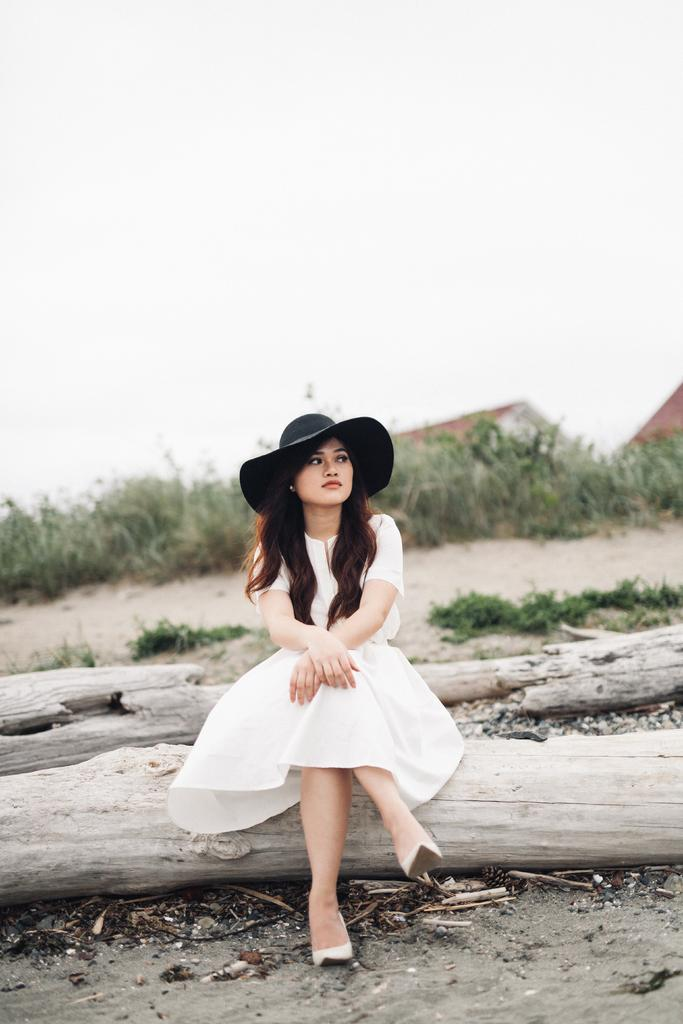What is the woman doing in the image? The woman is seated on the tree bark in the image. What can be seen on the ground in the image? There are tree barks visible in the image. What type of vegetation is present in the image? There are plants in the image. What type of structures can be seen in the image? There are houses in the image. What is the condition of the sky in the image? The sky is cloudy in the image. What type of drum can be seen in the woman's hand in the image? There is no drum present in the image; the woman is not holding anything in her hand. 